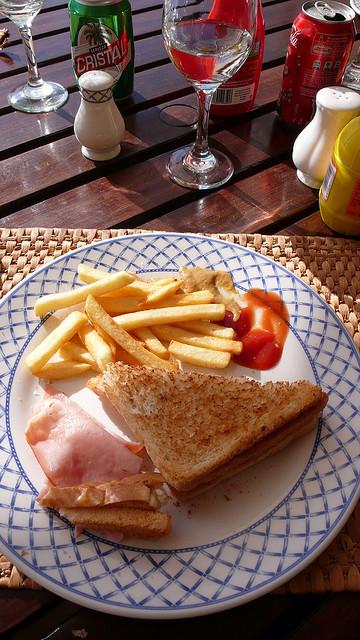Is there pepper nearby?
Give a very brief answer. Yes. Is this a turkey sandwich?
Give a very brief answer. No. Does the person like eating the crusts of the sandwich?
Answer briefly. No. 